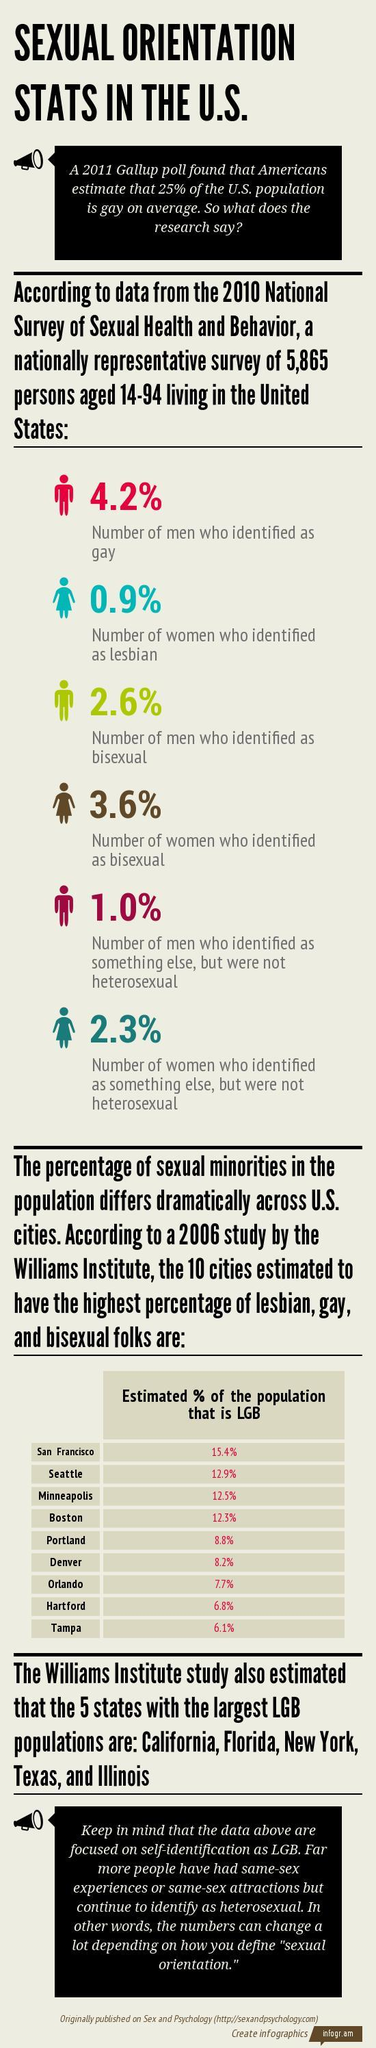Which city has  estimated the highest percentage of LGB population according to study by the Williams Institute in U.S.?
Answer the question with a short phrase. San Francisco What is the estimate percentage of LGB population in Boston? 12.3% Which city has estimated the least percentage of LGB population according to study by the Williams Institute in U.S.? Tampa 